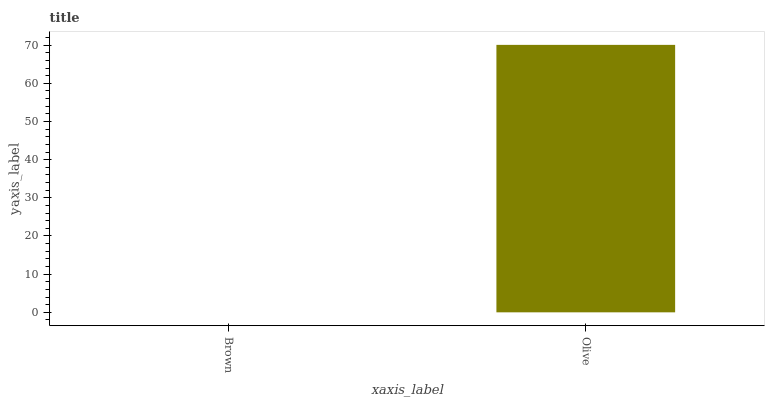Is Brown the minimum?
Answer yes or no. Yes. Is Olive the maximum?
Answer yes or no. Yes. Is Olive the minimum?
Answer yes or no. No. Is Olive greater than Brown?
Answer yes or no. Yes. Is Brown less than Olive?
Answer yes or no. Yes. Is Brown greater than Olive?
Answer yes or no. No. Is Olive less than Brown?
Answer yes or no. No. Is Olive the high median?
Answer yes or no. Yes. Is Brown the low median?
Answer yes or no. Yes. Is Brown the high median?
Answer yes or no. No. Is Olive the low median?
Answer yes or no. No. 